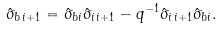<formula> <loc_0><loc_0><loc_500><loc_500>\hat { \sigma } _ { b \, i + 1 } = \hat { \sigma } _ { b i } \hat { \sigma } _ { i \, i + 1 } - q ^ { - 1 } \hat { \sigma } _ { i \, i + 1 } \hat { \sigma } _ { b i } .</formula> 